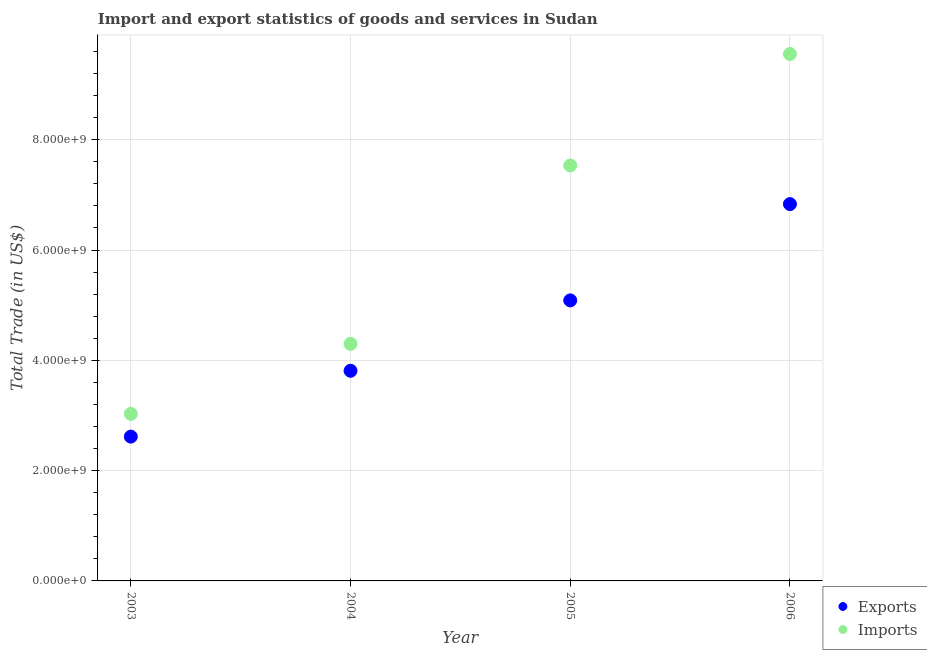Is the number of dotlines equal to the number of legend labels?
Provide a short and direct response. Yes. What is the export of goods and services in 2004?
Ensure brevity in your answer.  3.81e+09. Across all years, what is the maximum export of goods and services?
Your response must be concise. 6.83e+09. Across all years, what is the minimum export of goods and services?
Your response must be concise. 2.62e+09. In which year was the imports of goods and services maximum?
Your answer should be compact. 2006. What is the total export of goods and services in the graph?
Your answer should be compact. 1.83e+1. What is the difference between the imports of goods and services in 2003 and that in 2005?
Give a very brief answer. -4.50e+09. What is the difference between the imports of goods and services in 2004 and the export of goods and services in 2005?
Give a very brief answer. -7.88e+08. What is the average imports of goods and services per year?
Provide a succinct answer. 6.10e+09. In the year 2003, what is the difference between the export of goods and services and imports of goods and services?
Give a very brief answer. -4.13e+08. What is the ratio of the export of goods and services in 2003 to that in 2004?
Your answer should be compact. 0.69. Is the difference between the export of goods and services in 2003 and 2006 greater than the difference between the imports of goods and services in 2003 and 2006?
Offer a terse response. Yes. What is the difference between the highest and the second highest export of goods and services?
Make the answer very short. 1.75e+09. What is the difference between the highest and the lowest imports of goods and services?
Keep it short and to the point. 6.52e+09. In how many years, is the imports of goods and services greater than the average imports of goods and services taken over all years?
Make the answer very short. 2. Is the sum of the imports of goods and services in 2004 and 2006 greater than the maximum export of goods and services across all years?
Give a very brief answer. Yes. Does the export of goods and services monotonically increase over the years?
Make the answer very short. Yes. Is the export of goods and services strictly greater than the imports of goods and services over the years?
Your answer should be very brief. No. Is the export of goods and services strictly less than the imports of goods and services over the years?
Provide a succinct answer. Yes. How many years are there in the graph?
Provide a short and direct response. 4. What is the difference between two consecutive major ticks on the Y-axis?
Keep it short and to the point. 2.00e+09. Are the values on the major ticks of Y-axis written in scientific E-notation?
Your response must be concise. Yes. Does the graph contain any zero values?
Offer a very short reply. No. How many legend labels are there?
Your answer should be very brief. 2. What is the title of the graph?
Your answer should be compact. Import and export statistics of goods and services in Sudan. Does "Money lenders" appear as one of the legend labels in the graph?
Offer a terse response. No. What is the label or title of the Y-axis?
Make the answer very short. Total Trade (in US$). What is the Total Trade (in US$) in Exports in 2003?
Make the answer very short. 2.62e+09. What is the Total Trade (in US$) of Imports in 2003?
Give a very brief answer. 3.03e+09. What is the Total Trade (in US$) in Exports in 2004?
Make the answer very short. 3.81e+09. What is the Total Trade (in US$) in Imports in 2004?
Make the answer very short. 4.30e+09. What is the Total Trade (in US$) of Exports in 2005?
Make the answer very short. 5.09e+09. What is the Total Trade (in US$) in Imports in 2005?
Provide a short and direct response. 7.53e+09. What is the Total Trade (in US$) in Exports in 2006?
Keep it short and to the point. 6.83e+09. What is the Total Trade (in US$) in Imports in 2006?
Offer a terse response. 9.55e+09. Across all years, what is the maximum Total Trade (in US$) in Exports?
Keep it short and to the point. 6.83e+09. Across all years, what is the maximum Total Trade (in US$) in Imports?
Your answer should be very brief. 9.55e+09. Across all years, what is the minimum Total Trade (in US$) in Exports?
Your answer should be compact. 2.62e+09. Across all years, what is the minimum Total Trade (in US$) in Imports?
Keep it short and to the point. 3.03e+09. What is the total Total Trade (in US$) of Exports in the graph?
Give a very brief answer. 1.83e+1. What is the total Total Trade (in US$) in Imports in the graph?
Keep it short and to the point. 2.44e+1. What is the difference between the Total Trade (in US$) of Exports in 2003 and that in 2004?
Provide a short and direct response. -1.19e+09. What is the difference between the Total Trade (in US$) of Imports in 2003 and that in 2004?
Your response must be concise. -1.27e+09. What is the difference between the Total Trade (in US$) of Exports in 2003 and that in 2005?
Give a very brief answer. -2.47e+09. What is the difference between the Total Trade (in US$) in Imports in 2003 and that in 2005?
Your response must be concise. -4.50e+09. What is the difference between the Total Trade (in US$) in Exports in 2003 and that in 2006?
Make the answer very short. -4.22e+09. What is the difference between the Total Trade (in US$) in Imports in 2003 and that in 2006?
Keep it short and to the point. -6.52e+09. What is the difference between the Total Trade (in US$) of Exports in 2004 and that in 2005?
Keep it short and to the point. -1.28e+09. What is the difference between the Total Trade (in US$) in Imports in 2004 and that in 2005?
Make the answer very short. -3.24e+09. What is the difference between the Total Trade (in US$) of Exports in 2004 and that in 2006?
Your answer should be very brief. -3.02e+09. What is the difference between the Total Trade (in US$) of Imports in 2004 and that in 2006?
Give a very brief answer. -5.26e+09. What is the difference between the Total Trade (in US$) in Exports in 2005 and that in 2006?
Your answer should be very brief. -1.75e+09. What is the difference between the Total Trade (in US$) of Imports in 2005 and that in 2006?
Provide a short and direct response. -2.02e+09. What is the difference between the Total Trade (in US$) in Exports in 2003 and the Total Trade (in US$) in Imports in 2004?
Give a very brief answer. -1.68e+09. What is the difference between the Total Trade (in US$) in Exports in 2003 and the Total Trade (in US$) in Imports in 2005?
Make the answer very short. -4.92e+09. What is the difference between the Total Trade (in US$) in Exports in 2003 and the Total Trade (in US$) in Imports in 2006?
Your answer should be compact. -6.94e+09. What is the difference between the Total Trade (in US$) in Exports in 2004 and the Total Trade (in US$) in Imports in 2005?
Offer a terse response. -3.72e+09. What is the difference between the Total Trade (in US$) in Exports in 2004 and the Total Trade (in US$) in Imports in 2006?
Keep it short and to the point. -5.74e+09. What is the difference between the Total Trade (in US$) in Exports in 2005 and the Total Trade (in US$) in Imports in 2006?
Your response must be concise. -4.47e+09. What is the average Total Trade (in US$) of Exports per year?
Ensure brevity in your answer.  4.59e+09. What is the average Total Trade (in US$) in Imports per year?
Your answer should be compact. 6.10e+09. In the year 2003, what is the difference between the Total Trade (in US$) of Exports and Total Trade (in US$) of Imports?
Offer a very short reply. -4.13e+08. In the year 2004, what is the difference between the Total Trade (in US$) in Exports and Total Trade (in US$) in Imports?
Offer a terse response. -4.88e+08. In the year 2005, what is the difference between the Total Trade (in US$) in Exports and Total Trade (in US$) in Imports?
Offer a terse response. -2.45e+09. In the year 2006, what is the difference between the Total Trade (in US$) of Exports and Total Trade (in US$) of Imports?
Keep it short and to the point. -2.72e+09. What is the ratio of the Total Trade (in US$) in Exports in 2003 to that in 2004?
Ensure brevity in your answer.  0.69. What is the ratio of the Total Trade (in US$) in Imports in 2003 to that in 2004?
Make the answer very short. 0.7. What is the ratio of the Total Trade (in US$) in Exports in 2003 to that in 2005?
Your response must be concise. 0.51. What is the ratio of the Total Trade (in US$) of Imports in 2003 to that in 2005?
Your response must be concise. 0.4. What is the ratio of the Total Trade (in US$) in Exports in 2003 to that in 2006?
Offer a terse response. 0.38. What is the ratio of the Total Trade (in US$) of Imports in 2003 to that in 2006?
Provide a succinct answer. 0.32. What is the ratio of the Total Trade (in US$) in Exports in 2004 to that in 2005?
Make the answer very short. 0.75. What is the ratio of the Total Trade (in US$) of Imports in 2004 to that in 2005?
Your answer should be very brief. 0.57. What is the ratio of the Total Trade (in US$) in Exports in 2004 to that in 2006?
Your response must be concise. 0.56. What is the ratio of the Total Trade (in US$) in Imports in 2004 to that in 2006?
Ensure brevity in your answer.  0.45. What is the ratio of the Total Trade (in US$) in Exports in 2005 to that in 2006?
Provide a short and direct response. 0.74. What is the ratio of the Total Trade (in US$) in Imports in 2005 to that in 2006?
Ensure brevity in your answer.  0.79. What is the difference between the highest and the second highest Total Trade (in US$) in Exports?
Offer a terse response. 1.75e+09. What is the difference between the highest and the second highest Total Trade (in US$) of Imports?
Keep it short and to the point. 2.02e+09. What is the difference between the highest and the lowest Total Trade (in US$) of Exports?
Your answer should be very brief. 4.22e+09. What is the difference between the highest and the lowest Total Trade (in US$) of Imports?
Provide a short and direct response. 6.52e+09. 